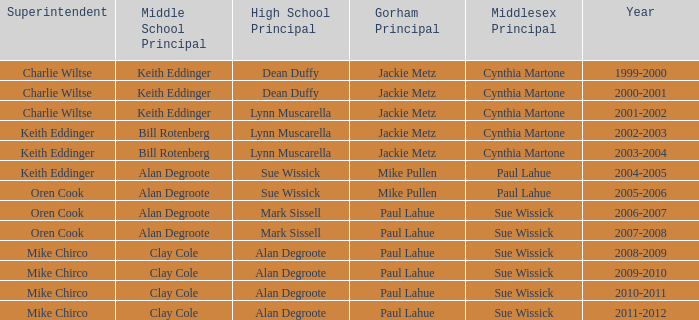Who were the superintendent(s) when the middle school principal was alan degroote, the gorham principal was paul lahue, and the year was 2006-2007? Oren Cook. 